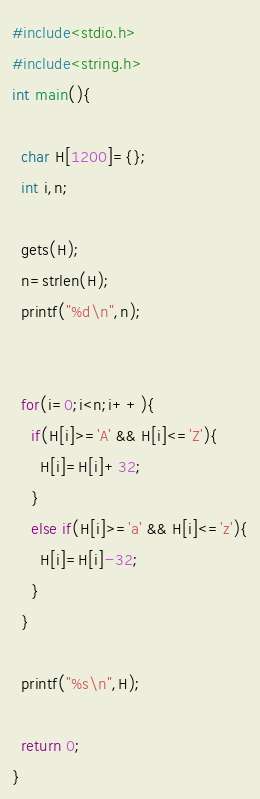<code> <loc_0><loc_0><loc_500><loc_500><_C_>#include<stdio.h>
#include<string.h>
int main(){
  
  char H[1200]={};
  int i,n;
  
  gets(H);
  n=strlen(H);
  printf("%d\n",n);
  
  
  for(i=0;i<n;i++){
    if(H[i]>='A' && H[i]<='Z'){
      H[i]=H[i]+32;
    }
    else if(H[i]>='a' && H[i]<='z'){
      H[i]=H[i]-32;
    }
  }
  
  printf("%s\n",H);
  
  return 0;
}</code> 